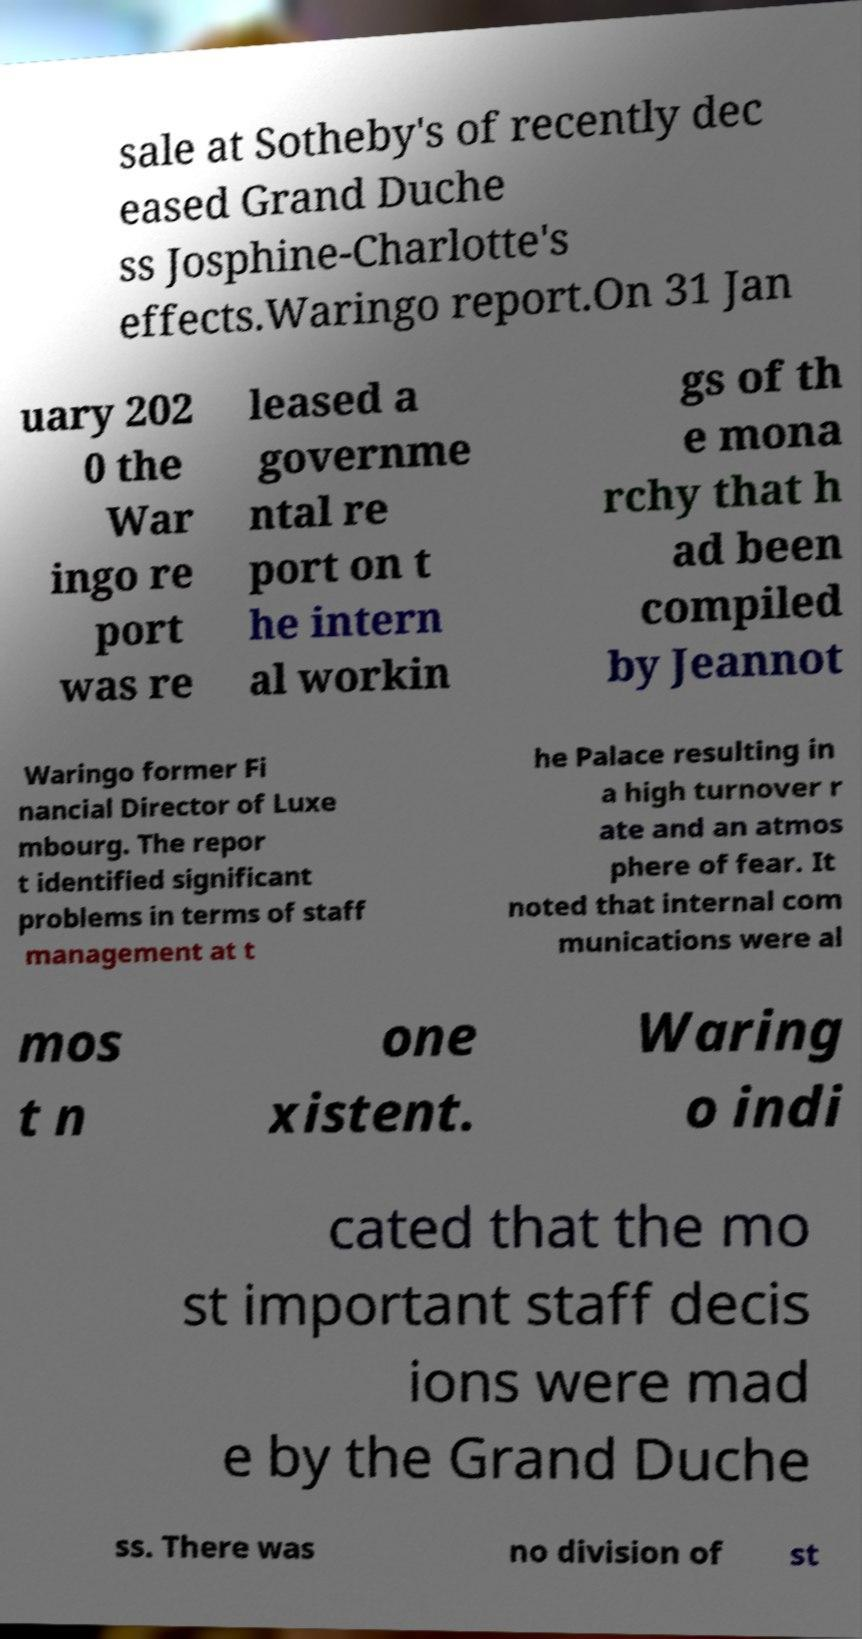Can you accurately transcribe the text from the provided image for me? sale at Sotheby's of recently dec eased Grand Duche ss Josphine-Charlotte's effects.Waringo report.On 31 Jan uary 202 0 the War ingo re port was re leased a governme ntal re port on t he intern al workin gs of th e mona rchy that h ad been compiled by Jeannot Waringo former Fi nancial Director of Luxe mbourg. The repor t identified significant problems in terms of staff management at t he Palace resulting in a high turnover r ate and an atmos phere of fear. It noted that internal com munications were al mos t n one xistent. Waring o indi cated that the mo st important staff decis ions were mad e by the Grand Duche ss. There was no division of st 